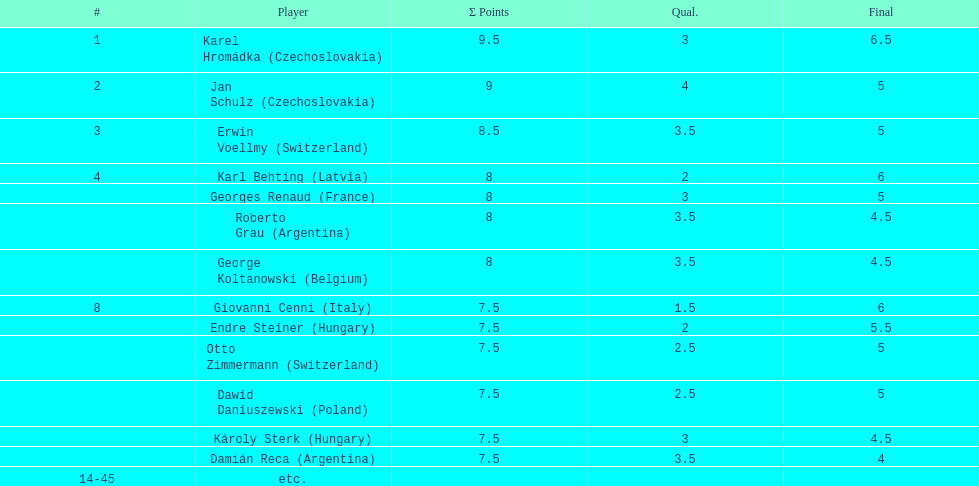What number of players achieved 8 points? 4. 